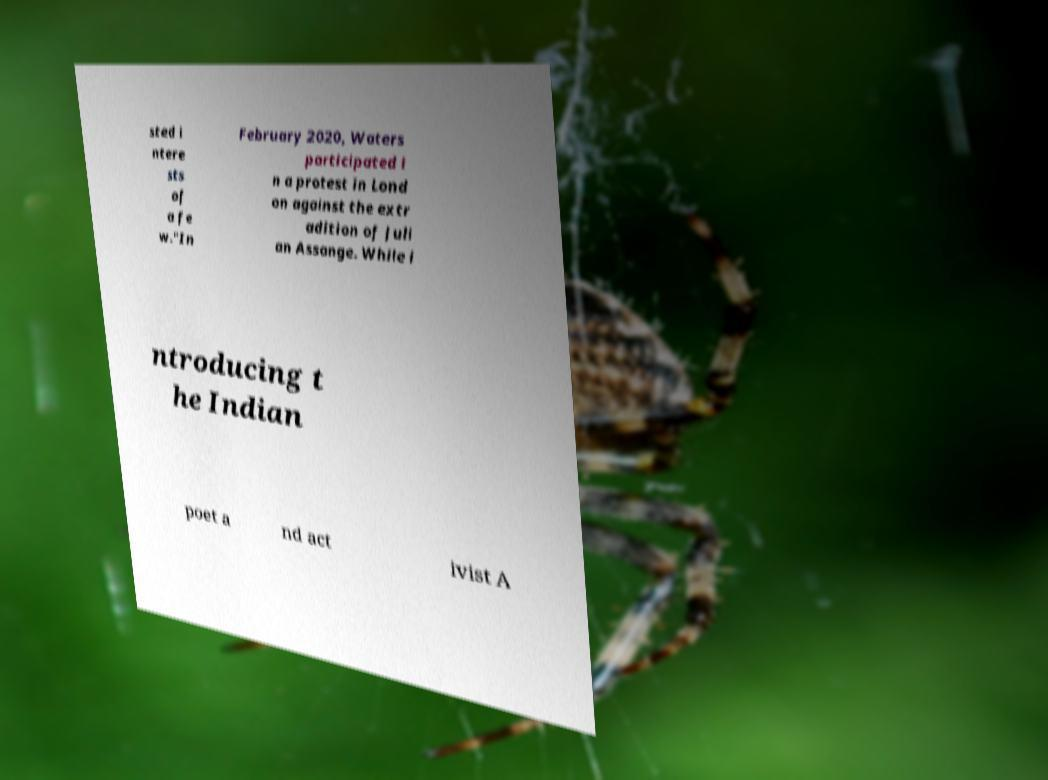Please read and relay the text visible in this image. What does it say? sted i ntere sts of a fe w."In February 2020, Waters participated i n a protest in Lond on against the extr adition of Juli an Assange. While i ntroducing t he Indian poet a nd act ivist A 